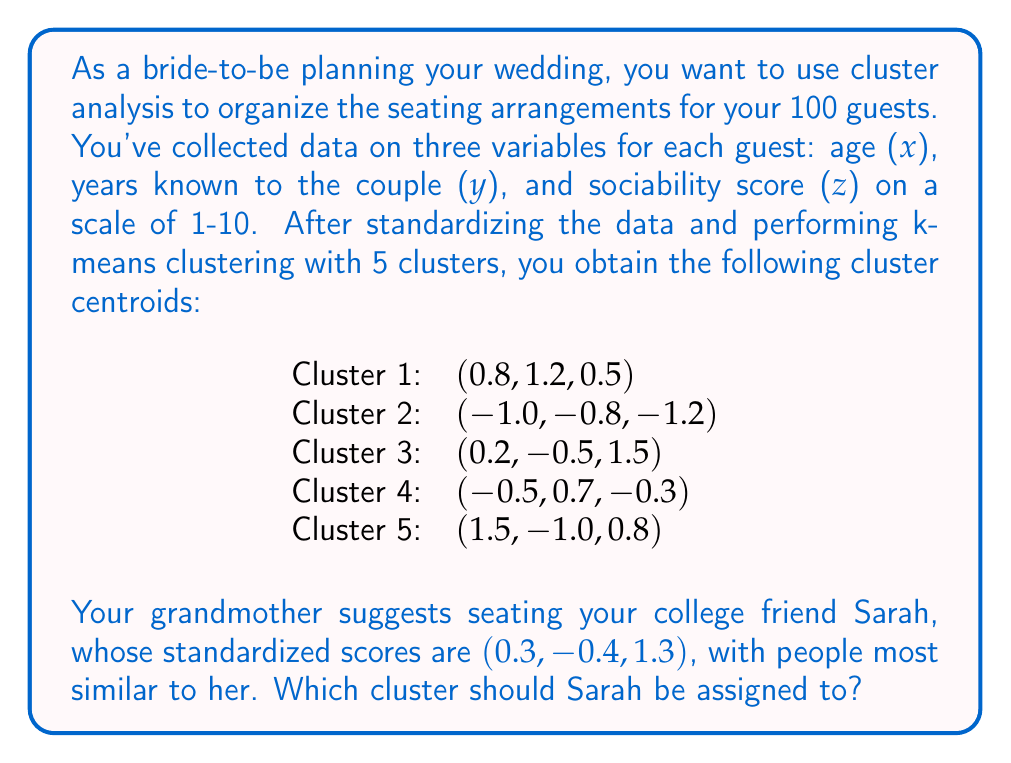Help me with this question. To determine which cluster Sarah should be assigned to, we need to calculate the Euclidean distance between Sarah's standardized scores and each cluster centroid. The cluster with the smallest distance will be the most appropriate for Sarah.

Let's calculate the distance to each cluster:

1. Distance to Cluster 1:
   $$d_1 = \sqrt{(0.3-0.8)^2 + (-0.4-1.2)^2 + (1.3-0.5)^2} = \sqrt{0.25 + 2.56 + 0.64} = \sqrt{3.45} \approx 1.86$$

2. Distance to Cluster 2:
   $$d_2 = \sqrt{(0.3-(-1.0))^2 + (-0.4-(-0.8))^2 + (1.3-(-1.2))^2} = \sqrt{1.69 + 0.16 + 6.25} = \sqrt{8.10} \approx 2.85$$

3. Distance to Cluster 3:
   $$d_3 = \sqrt{(0.3-0.2)^2 + (-0.4-(-0.5))^2 + (1.3-1.5)^2} = \sqrt{0.01 + 0.01 + 0.04} = \sqrt{0.06} \approx 0.24$$

4. Distance to Cluster 4:
   $$d_4 = \sqrt{(0.3-(-0.5))^2 + (-0.4-0.7)^2 + (1.3-(-0.3))^2} = \sqrt{0.64 + 1.21 + 2.56} = \sqrt{4.41} \approx 2.10$$

5. Distance to Cluster 5:
   $$d_5 = \sqrt{(0.3-1.5)^2 + (-0.4-(-1.0))^2 + (1.3-0.8)^2} = \sqrt{1.44 + 0.36 + 0.25} = \sqrt{2.05} \approx 1.43$$

The smallest distance is to Cluster 3, which is approximately 0.24.
Answer: Sarah should be assigned to Cluster 3. 